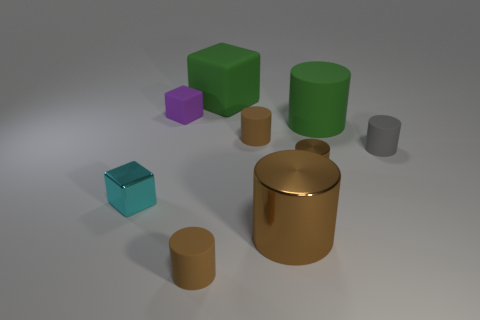Subtract all brown cylinders. How many were subtracted if there are1brown cylinders left? 3 Subtract all cyan blocks. How many blocks are left? 2 Add 1 large purple objects. How many objects exist? 10 Subtract all gray cylinders. How many cylinders are left? 5 Subtract 2 cubes. How many cubes are left? 1 Subtract all yellow spheres. How many brown cylinders are left? 4 Subtract all cylinders. How many objects are left? 3 Subtract all big green cylinders. Subtract all large brown things. How many objects are left? 7 Add 2 cubes. How many cubes are left? 5 Add 1 yellow balls. How many yellow balls exist? 1 